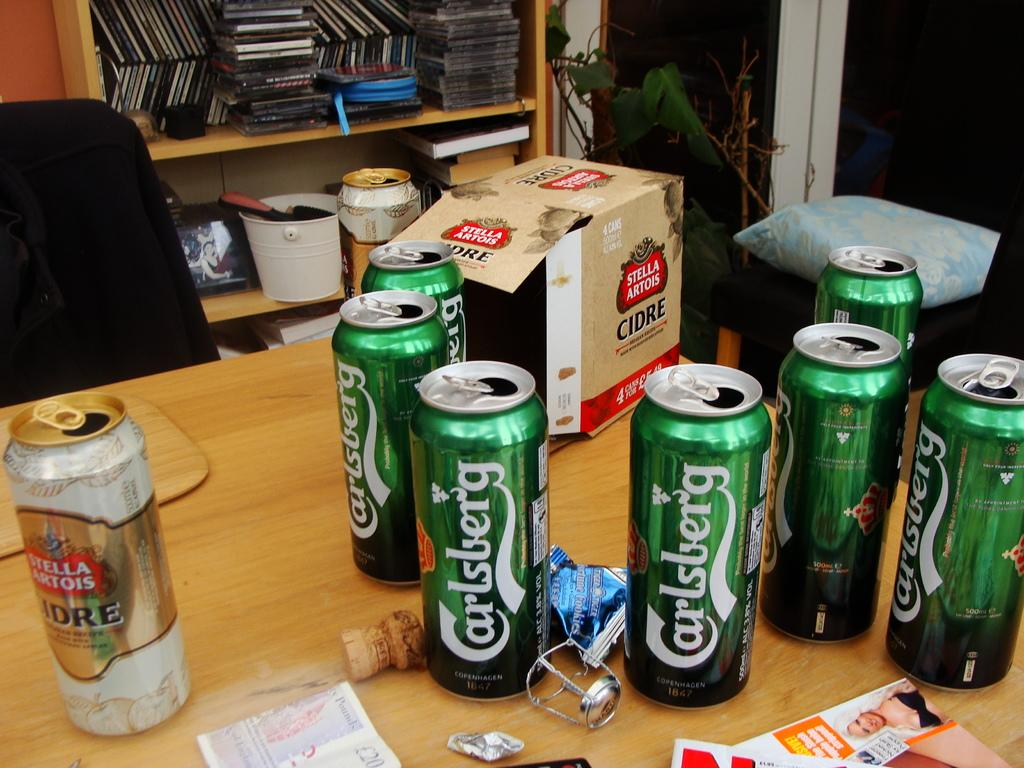<image>
Summarize the visual content of the image. Several open cans of Carlsberg beer are on a desk. 